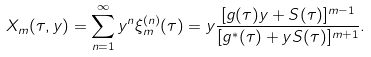Convert formula to latex. <formula><loc_0><loc_0><loc_500><loc_500>X _ { m } ( \tau , y ) = \sum _ { n = 1 } ^ { \infty } y ^ { n } \xi _ { m } ^ { ( n ) } ( \tau ) = y \frac { [ g ( \tau ) y + S ( \tau ) ] ^ { m - 1 } } { [ g ^ { * } ( \tau ) + y S ( \tau ) ] ^ { m + 1 } } .</formula> 